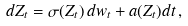<formula> <loc_0><loc_0><loc_500><loc_500>d Z _ { t } = \sigma ( Z _ { t } ) \, d w _ { t } + a ( Z _ { t } ) d t \, ,</formula> 